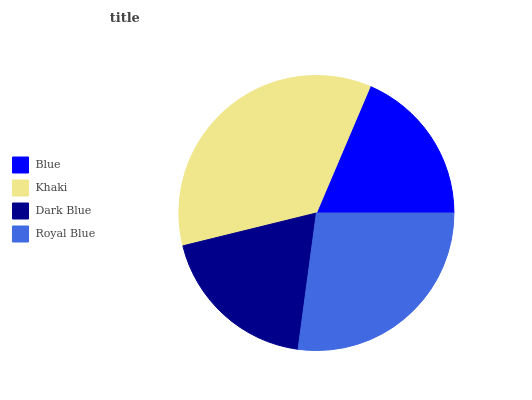Is Blue the minimum?
Answer yes or no. Yes. Is Khaki the maximum?
Answer yes or no. Yes. Is Dark Blue the minimum?
Answer yes or no. No. Is Dark Blue the maximum?
Answer yes or no. No. Is Khaki greater than Dark Blue?
Answer yes or no. Yes. Is Dark Blue less than Khaki?
Answer yes or no. Yes. Is Dark Blue greater than Khaki?
Answer yes or no. No. Is Khaki less than Dark Blue?
Answer yes or no. No. Is Royal Blue the high median?
Answer yes or no. Yes. Is Dark Blue the low median?
Answer yes or no. Yes. Is Khaki the high median?
Answer yes or no. No. Is Royal Blue the low median?
Answer yes or no. No. 